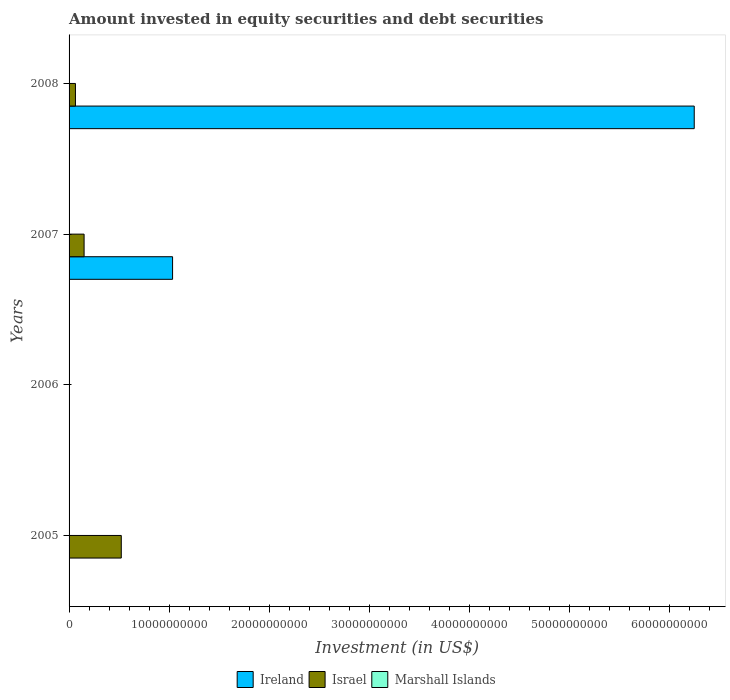How many different coloured bars are there?
Keep it short and to the point. 3. In how many cases, is the number of bars for a given year not equal to the number of legend labels?
Give a very brief answer. 3. What is the amount invested in equity securities and debt securities in Israel in 2008?
Provide a short and direct response. 6.38e+08. Across all years, what is the maximum amount invested in equity securities and debt securities in Ireland?
Ensure brevity in your answer.  6.25e+1. Across all years, what is the minimum amount invested in equity securities and debt securities in Israel?
Provide a succinct answer. 0. In which year was the amount invested in equity securities and debt securities in Marshall Islands maximum?
Provide a succinct answer. 2007. What is the total amount invested in equity securities and debt securities in Ireland in the graph?
Make the answer very short. 7.28e+1. What is the difference between the amount invested in equity securities and debt securities in Ireland in 2007 and that in 2008?
Offer a very short reply. -5.21e+1. What is the difference between the amount invested in equity securities and debt securities in Israel in 2008 and the amount invested in equity securities and debt securities in Marshall Islands in 2007?
Provide a succinct answer. 6.36e+08. What is the average amount invested in equity securities and debt securities in Ireland per year?
Your answer should be very brief. 1.82e+1. In the year 2007, what is the difference between the amount invested in equity securities and debt securities in Marshall Islands and amount invested in equity securities and debt securities in Israel?
Offer a very short reply. -1.50e+09. In how many years, is the amount invested in equity securities and debt securities in Israel greater than 48000000000 US$?
Ensure brevity in your answer.  0. What is the ratio of the amount invested in equity securities and debt securities in Israel in 2007 to that in 2008?
Ensure brevity in your answer.  2.35. What is the difference between the highest and the lowest amount invested in equity securities and debt securities in Ireland?
Your response must be concise. 6.25e+1. In how many years, is the amount invested in equity securities and debt securities in Israel greater than the average amount invested in equity securities and debt securities in Israel taken over all years?
Your answer should be compact. 1. Are the values on the major ticks of X-axis written in scientific E-notation?
Your answer should be very brief. No. How many legend labels are there?
Provide a short and direct response. 3. How are the legend labels stacked?
Keep it short and to the point. Horizontal. What is the title of the graph?
Your response must be concise. Amount invested in equity securities and debt securities. What is the label or title of the X-axis?
Your response must be concise. Investment (in US$). What is the Investment (in US$) in Ireland in 2005?
Give a very brief answer. 0. What is the Investment (in US$) in Israel in 2005?
Ensure brevity in your answer.  5.22e+09. What is the Investment (in US$) in Marshall Islands in 2005?
Give a very brief answer. 0. What is the Investment (in US$) of Marshall Islands in 2006?
Keep it short and to the point. 0. What is the Investment (in US$) in Ireland in 2007?
Keep it short and to the point. 1.03e+1. What is the Investment (in US$) of Israel in 2007?
Ensure brevity in your answer.  1.50e+09. What is the Investment (in US$) in Marshall Islands in 2007?
Your response must be concise. 1.97e+06. What is the Investment (in US$) in Ireland in 2008?
Give a very brief answer. 6.25e+1. What is the Investment (in US$) in Israel in 2008?
Your answer should be compact. 6.38e+08. What is the Investment (in US$) in Marshall Islands in 2008?
Make the answer very short. 0. Across all years, what is the maximum Investment (in US$) of Ireland?
Provide a short and direct response. 6.25e+1. Across all years, what is the maximum Investment (in US$) of Israel?
Provide a short and direct response. 5.22e+09. Across all years, what is the maximum Investment (in US$) in Marshall Islands?
Offer a very short reply. 1.97e+06. Across all years, what is the minimum Investment (in US$) of Israel?
Keep it short and to the point. 0. Across all years, what is the minimum Investment (in US$) in Marshall Islands?
Make the answer very short. 0. What is the total Investment (in US$) in Ireland in the graph?
Ensure brevity in your answer.  7.28e+1. What is the total Investment (in US$) of Israel in the graph?
Ensure brevity in your answer.  7.36e+09. What is the total Investment (in US$) of Marshall Islands in the graph?
Offer a terse response. 1.97e+06. What is the difference between the Investment (in US$) in Israel in 2005 and that in 2007?
Your answer should be compact. 3.72e+09. What is the difference between the Investment (in US$) in Israel in 2005 and that in 2008?
Your answer should be very brief. 4.58e+09. What is the difference between the Investment (in US$) of Ireland in 2007 and that in 2008?
Provide a succinct answer. -5.21e+1. What is the difference between the Investment (in US$) in Israel in 2007 and that in 2008?
Offer a very short reply. 8.63e+08. What is the difference between the Investment (in US$) in Israel in 2005 and the Investment (in US$) in Marshall Islands in 2007?
Offer a terse response. 5.22e+09. What is the difference between the Investment (in US$) of Ireland in 2007 and the Investment (in US$) of Israel in 2008?
Provide a short and direct response. 9.71e+09. What is the average Investment (in US$) in Ireland per year?
Provide a short and direct response. 1.82e+1. What is the average Investment (in US$) in Israel per year?
Offer a terse response. 1.84e+09. What is the average Investment (in US$) of Marshall Islands per year?
Ensure brevity in your answer.  4.92e+05. In the year 2007, what is the difference between the Investment (in US$) in Ireland and Investment (in US$) in Israel?
Provide a succinct answer. 8.84e+09. In the year 2007, what is the difference between the Investment (in US$) of Ireland and Investment (in US$) of Marshall Islands?
Offer a terse response. 1.03e+1. In the year 2007, what is the difference between the Investment (in US$) in Israel and Investment (in US$) in Marshall Islands?
Ensure brevity in your answer.  1.50e+09. In the year 2008, what is the difference between the Investment (in US$) of Ireland and Investment (in US$) of Israel?
Keep it short and to the point. 6.19e+1. What is the ratio of the Investment (in US$) of Israel in 2005 to that in 2007?
Ensure brevity in your answer.  3.48. What is the ratio of the Investment (in US$) in Israel in 2005 to that in 2008?
Your response must be concise. 8.18. What is the ratio of the Investment (in US$) in Ireland in 2007 to that in 2008?
Give a very brief answer. 0.17. What is the ratio of the Investment (in US$) of Israel in 2007 to that in 2008?
Your answer should be very brief. 2.35. What is the difference between the highest and the second highest Investment (in US$) of Israel?
Ensure brevity in your answer.  3.72e+09. What is the difference between the highest and the lowest Investment (in US$) in Ireland?
Your answer should be compact. 6.25e+1. What is the difference between the highest and the lowest Investment (in US$) of Israel?
Your response must be concise. 5.22e+09. What is the difference between the highest and the lowest Investment (in US$) of Marshall Islands?
Keep it short and to the point. 1.97e+06. 